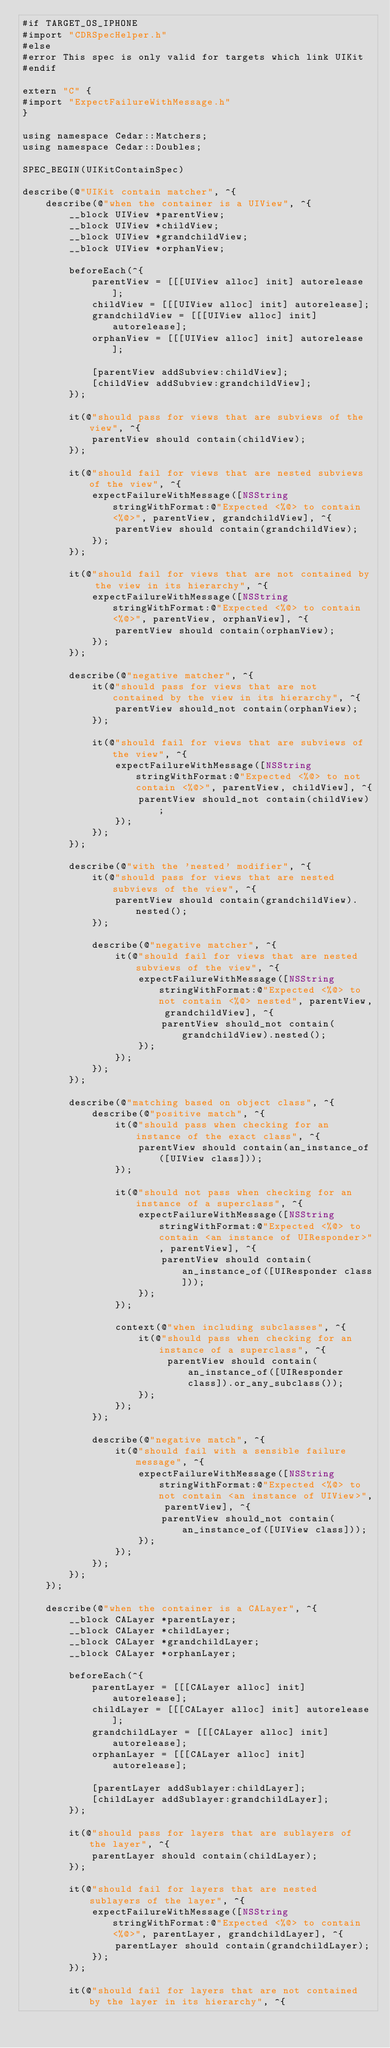<code> <loc_0><loc_0><loc_500><loc_500><_ObjectiveC_>#if TARGET_OS_IPHONE
#import "CDRSpecHelper.h"
#else
#error This spec is only valid for targets which link UIKit
#endif

extern "C" {
#import "ExpectFailureWithMessage.h"
}

using namespace Cedar::Matchers;
using namespace Cedar::Doubles;

SPEC_BEGIN(UIKitContainSpec)

describe(@"UIKit contain matcher", ^{
    describe(@"when the container is a UIView", ^{
        __block UIView *parentView;
        __block UIView *childView;
        __block UIView *grandchildView;
        __block UIView *orphanView;

        beforeEach(^{
            parentView = [[[UIView alloc] init] autorelease];
            childView = [[[UIView alloc] init] autorelease];
            grandchildView = [[[UIView alloc] init] autorelease];
            orphanView = [[[UIView alloc] init] autorelease];

            [parentView addSubview:childView];
            [childView addSubview:grandchildView];
        });

        it(@"should pass for views that are subviews of the view", ^{
            parentView should contain(childView);
        });

        it(@"should fail for views that are nested subviews of the view", ^{
            expectFailureWithMessage([NSString stringWithFormat:@"Expected <%@> to contain <%@>", parentView, grandchildView], ^{
                parentView should contain(grandchildView);
            });
        });

        it(@"should fail for views that are not contained by the view in its hierarchy", ^{
            expectFailureWithMessage([NSString stringWithFormat:@"Expected <%@> to contain <%@>", parentView, orphanView], ^{
                parentView should contain(orphanView);
            });
        });

        describe(@"negative matcher", ^{
            it(@"should pass for views that are not contained by the view in its hierarchy", ^{
                parentView should_not contain(orphanView);
            });

            it(@"should fail for views that are subviews of the view", ^{
                expectFailureWithMessage([NSString stringWithFormat:@"Expected <%@> to not contain <%@>", parentView, childView], ^{
                    parentView should_not contain(childView);
                });
            });
        });

        describe(@"with the 'nested' modifier", ^{
            it(@"should pass for views that are nested subviews of the view", ^{
                parentView should contain(grandchildView).nested();
            });

            describe(@"negative matcher", ^{
                it(@"should fail for views that are nested subviews of the view", ^{
                    expectFailureWithMessage([NSString stringWithFormat:@"Expected <%@> to not contain <%@> nested", parentView, grandchildView], ^{
                        parentView should_not contain(grandchildView).nested();
                    });
                });
            });
        });

        describe(@"matching based on object class", ^{
            describe(@"positive match", ^{
                it(@"should pass when checking for an instance of the exact class", ^{
                    parentView should contain(an_instance_of([UIView class]));
                });

                it(@"should not pass when checking for an instance of a superclass", ^{
                    expectFailureWithMessage([NSString stringWithFormat:@"Expected <%@> to contain <an instance of UIResponder>", parentView], ^{
                        parentView should contain(an_instance_of([UIResponder class]));
                    });
                });

                context(@"when including subclasses", ^{
                    it(@"should pass when checking for an instance of a superclass", ^{
                         parentView should contain(an_instance_of([UIResponder class]).or_any_subclass());
                    });
                });
            });

            describe(@"negative match", ^{
                it(@"should fail with a sensible failure message", ^{
                    expectFailureWithMessage([NSString stringWithFormat:@"Expected <%@> to not contain <an instance of UIView>", parentView], ^{
                        parentView should_not contain(an_instance_of([UIView class]));
                    });
                });
            });
        });
    });

    describe(@"when the container is a CALayer", ^{
        __block CALayer *parentLayer;
        __block CALayer *childLayer;
        __block CALayer *grandchildLayer;
        __block CALayer *orphanLayer;

        beforeEach(^{
            parentLayer = [[[CALayer alloc] init] autorelease];
            childLayer = [[[CALayer alloc] init] autorelease];
            grandchildLayer = [[[CALayer alloc] init] autorelease];
            orphanLayer = [[[CALayer alloc] init] autorelease];

            [parentLayer addSublayer:childLayer];
            [childLayer addSublayer:grandchildLayer];
        });

        it(@"should pass for layers that are sublayers of the layer", ^{
            parentLayer should contain(childLayer);
        });

        it(@"should fail for layers that are nested sublayers of the layer", ^{
            expectFailureWithMessage([NSString stringWithFormat:@"Expected <%@> to contain <%@>", parentLayer, grandchildLayer], ^{
                parentLayer should contain(grandchildLayer);
            });
        });

        it(@"should fail for layers that are not contained by the layer in its hierarchy", ^{</code> 